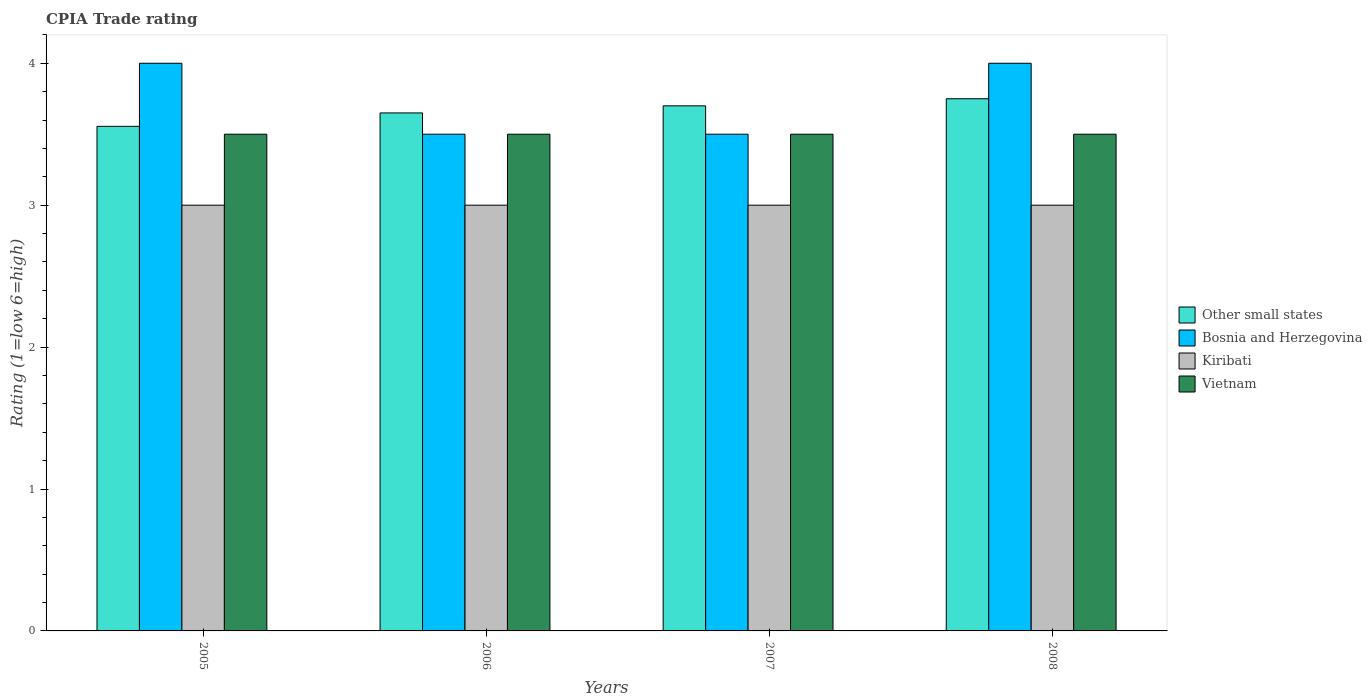Are the number of bars on each tick of the X-axis equal?
Keep it short and to the point. Yes. What is the label of the 4th group of bars from the left?
Your answer should be very brief. 2008. Across all years, what is the maximum CPIA rating in Bosnia and Herzegovina?
Your answer should be very brief. 4. Across all years, what is the minimum CPIA rating in Vietnam?
Provide a short and direct response. 3.5. In which year was the CPIA rating in Kiribati maximum?
Ensure brevity in your answer.  2005. In which year was the CPIA rating in Bosnia and Herzegovina minimum?
Offer a terse response. 2006. What is the total CPIA rating in Kiribati in the graph?
Make the answer very short. 12. What is the difference between the CPIA rating in Bosnia and Herzegovina in 2006 and that in 2008?
Make the answer very short. -0.5. What is the difference between the CPIA rating in Bosnia and Herzegovina in 2007 and the CPIA rating in Vietnam in 2008?
Keep it short and to the point. 0. What is the average CPIA rating in Other small states per year?
Your response must be concise. 3.66. What is the ratio of the CPIA rating in Kiribati in 2006 to that in 2008?
Offer a terse response. 1. Is the CPIA rating in Other small states in 2005 less than that in 2007?
Provide a short and direct response. Yes. What is the difference between the highest and the second highest CPIA rating in Vietnam?
Provide a short and direct response. 0. Is the sum of the CPIA rating in Other small states in 2005 and 2007 greater than the maximum CPIA rating in Bosnia and Herzegovina across all years?
Offer a very short reply. Yes. What does the 1st bar from the left in 2005 represents?
Keep it short and to the point. Other small states. What does the 1st bar from the right in 2006 represents?
Ensure brevity in your answer.  Vietnam. Are all the bars in the graph horizontal?
Your response must be concise. No. How many years are there in the graph?
Offer a terse response. 4. Are the values on the major ticks of Y-axis written in scientific E-notation?
Ensure brevity in your answer.  No. How are the legend labels stacked?
Ensure brevity in your answer.  Vertical. What is the title of the graph?
Offer a very short reply. CPIA Trade rating. What is the Rating (1=low 6=high) in Other small states in 2005?
Your answer should be very brief. 3.56. What is the Rating (1=low 6=high) in Bosnia and Herzegovina in 2005?
Offer a very short reply. 4. What is the Rating (1=low 6=high) in Other small states in 2006?
Ensure brevity in your answer.  3.65. What is the Rating (1=low 6=high) in Bosnia and Herzegovina in 2006?
Your response must be concise. 3.5. What is the Rating (1=low 6=high) of Kiribati in 2006?
Provide a short and direct response. 3. What is the Rating (1=low 6=high) of Kiribati in 2007?
Ensure brevity in your answer.  3. What is the Rating (1=low 6=high) in Other small states in 2008?
Your answer should be compact. 3.75. What is the Rating (1=low 6=high) in Bosnia and Herzegovina in 2008?
Offer a terse response. 4. What is the Rating (1=low 6=high) in Vietnam in 2008?
Offer a terse response. 3.5. Across all years, what is the maximum Rating (1=low 6=high) of Other small states?
Make the answer very short. 3.75. Across all years, what is the maximum Rating (1=low 6=high) in Bosnia and Herzegovina?
Offer a very short reply. 4. Across all years, what is the maximum Rating (1=low 6=high) in Kiribati?
Make the answer very short. 3. Across all years, what is the maximum Rating (1=low 6=high) in Vietnam?
Offer a terse response. 3.5. Across all years, what is the minimum Rating (1=low 6=high) in Other small states?
Your answer should be very brief. 3.56. Across all years, what is the minimum Rating (1=low 6=high) in Bosnia and Herzegovina?
Your answer should be compact. 3.5. Across all years, what is the minimum Rating (1=low 6=high) in Vietnam?
Make the answer very short. 3.5. What is the total Rating (1=low 6=high) of Other small states in the graph?
Offer a terse response. 14.66. What is the total Rating (1=low 6=high) of Bosnia and Herzegovina in the graph?
Provide a succinct answer. 15. What is the difference between the Rating (1=low 6=high) in Other small states in 2005 and that in 2006?
Offer a very short reply. -0.09. What is the difference between the Rating (1=low 6=high) of Other small states in 2005 and that in 2007?
Ensure brevity in your answer.  -0.14. What is the difference between the Rating (1=low 6=high) of Bosnia and Herzegovina in 2005 and that in 2007?
Make the answer very short. 0.5. What is the difference between the Rating (1=low 6=high) of Kiribati in 2005 and that in 2007?
Give a very brief answer. 0. What is the difference between the Rating (1=low 6=high) of Other small states in 2005 and that in 2008?
Offer a terse response. -0.19. What is the difference between the Rating (1=low 6=high) in Bosnia and Herzegovina in 2005 and that in 2008?
Ensure brevity in your answer.  0. What is the difference between the Rating (1=low 6=high) of Kiribati in 2005 and that in 2008?
Your answer should be very brief. 0. What is the difference between the Rating (1=low 6=high) in Kiribati in 2006 and that in 2007?
Ensure brevity in your answer.  0. What is the difference between the Rating (1=low 6=high) of Bosnia and Herzegovina in 2006 and that in 2008?
Provide a succinct answer. -0.5. What is the difference between the Rating (1=low 6=high) of Kiribati in 2007 and that in 2008?
Your answer should be very brief. 0. What is the difference between the Rating (1=low 6=high) in Other small states in 2005 and the Rating (1=low 6=high) in Bosnia and Herzegovina in 2006?
Your answer should be very brief. 0.06. What is the difference between the Rating (1=low 6=high) of Other small states in 2005 and the Rating (1=low 6=high) of Kiribati in 2006?
Make the answer very short. 0.56. What is the difference between the Rating (1=low 6=high) of Other small states in 2005 and the Rating (1=low 6=high) of Vietnam in 2006?
Your answer should be compact. 0.06. What is the difference between the Rating (1=low 6=high) in Bosnia and Herzegovina in 2005 and the Rating (1=low 6=high) in Kiribati in 2006?
Your response must be concise. 1. What is the difference between the Rating (1=low 6=high) of Other small states in 2005 and the Rating (1=low 6=high) of Bosnia and Herzegovina in 2007?
Offer a very short reply. 0.06. What is the difference between the Rating (1=low 6=high) in Other small states in 2005 and the Rating (1=low 6=high) in Kiribati in 2007?
Your answer should be compact. 0.56. What is the difference between the Rating (1=low 6=high) of Other small states in 2005 and the Rating (1=low 6=high) of Vietnam in 2007?
Offer a very short reply. 0.06. What is the difference between the Rating (1=low 6=high) of Bosnia and Herzegovina in 2005 and the Rating (1=low 6=high) of Kiribati in 2007?
Offer a terse response. 1. What is the difference between the Rating (1=low 6=high) of Other small states in 2005 and the Rating (1=low 6=high) of Bosnia and Herzegovina in 2008?
Provide a succinct answer. -0.44. What is the difference between the Rating (1=low 6=high) of Other small states in 2005 and the Rating (1=low 6=high) of Kiribati in 2008?
Make the answer very short. 0.56. What is the difference between the Rating (1=low 6=high) in Other small states in 2005 and the Rating (1=low 6=high) in Vietnam in 2008?
Make the answer very short. 0.06. What is the difference between the Rating (1=low 6=high) in Other small states in 2006 and the Rating (1=low 6=high) in Bosnia and Herzegovina in 2007?
Your response must be concise. 0.15. What is the difference between the Rating (1=low 6=high) of Other small states in 2006 and the Rating (1=low 6=high) of Kiribati in 2007?
Offer a terse response. 0.65. What is the difference between the Rating (1=low 6=high) of Bosnia and Herzegovina in 2006 and the Rating (1=low 6=high) of Kiribati in 2007?
Offer a terse response. 0.5. What is the difference between the Rating (1=low 6=high) in Other small states in 2006 and the Rating (1=low 6=high) in Bosnia and Herzegovina in 2008?
Your answer should be very brief. -0.35. What is the difference between the Rating (1=low 6=high) in Other small states in 2006 and the Rating (1=low 6=high) in Kiribati in 2008?
Offer a terse response. 0.65. What is the difference between the Rating (1=low 6=high) of Kiribati in 2006 and the Rating (1=low 6=high) of Vietnam in 2008?
Your response must be concise. -0.5. What is the difference between the Rating (1=low 6=high) of Other small states in 2007 and the Rating (1=low 6=high) of Kiribati in 2008?
Give a very brief answer. 0.7. What is the difference between the Rating (1=low 6=high) of Other small states in 2007 and the Rating (1=low 6=high) of Vietnam in 2008?
Your answer should be very brief. 0.2. What is the difference between the Rating (1=low 6=high) of Bosnia and Herzegovina in 2007 and the Rating (1=low 6=high) of Kiribati in 2008?
Ensure brevity in your answer.  0.5. What is the average Rating (1=low 6=high) in Other small states per year?
Give a very brief answer. 3.66. What is the average Rating (1=low 6=high) of Bosnia and Herzegovina per year?
Make the answer very short. 3.75. What is the average Rating (1=low 6=high) in Kiribati per year?
Make the answer very short. 3. What is the average Rating (1=low 6=high) of Vietnam per year?
Provide a short and direct response. 3.5. In the year 2005, what is the difference between the Rating (1=low 6=high) of Other small states and Rating (1=low 6=high) of Bosnia and Herzegovina?
Provide a short and direct response. -0.44. In the year 2005, what is the difference between the Rating (1=low 6=high) in Other small states and Rating (1=low 6=high) in Kiribati?
Offer a terse response. 0.56. In the year 2005, what is the difference between the Rating (1=low 6=high) in Other small states and Rating (1=low 6=high) in Vietnam?
Your answer should be compact. 0.06. In the year 2005, what is the difference between the Rating (1=low 6=high) of Bosnia and Herzegovina and Rating (1=low 6=high) of Kiribati?
Provide a short and direct response. 1. In the year 2005, what is the difference between the Rating (1=low 6=high) of Kiribati and Rating (1=low 6=high) of Vietnam?
Keep it short and to the point. -0.5. In the year 2006, what is the difference between the Rating (1=low 6=high) in Other small states and Rating (1=low 6=high) in Bosnia and Herzegovina?
Ensure brevity in your answer.  0.15. In the year 2006, what is the difference between the Rating (1=low 6=high) of Other small states and Rating (1=low 6=high) of Kiribati?
Keep it short and to the point. 0.65. In the year 2006, what is the difference between the Rating (1=low 6=high) of Other small states and Rating (1=low 6=high) of Vietnam?
Your response must be concise. 0.15. In the year 2006, what is the difference between the Rating (1=low 6=high) of Bosnia and Herzegovina and Rating (1=low 6=high) of Kiribati?
Give a very brief answer. 0.5. In the year 2006, what is the difference between the Rating (1=low 6=high) of Bosnia and Herzegovina and Rating (1=low 6=high) of Vietnam?
Your answer should be compact. 0. In the year 2006, what is the difference between the Rating (1=low 6=high) of Kiribati and Rating (1=low 6=high) of Vietnam?
Offer a very short reply. -0.5. In the year 2007, what is the difference between the Rating (1=low 6=high) in Other small states and Rating (1=low 6=high) in Bosnia and Herzegovina?
Keep it short and to the point. 0.2. In the year 2007, what is the difference between the Rating (1=low 6=high) of Kiribati and Rating (1=low 6=high) of Vietnam?
Provide a succinct answer. -0.5. In the year 2008, what is the difference between the Rating (1=low 6=high) in Other small states and Rating (1=low 6=high) in Bosnia and Herzegovina?
Your response must be concise. -0.25. In the year 2008, what is the difference between the Rating (1=low 6=high) of Bosnia and Herzegovina and Rating (1=low 6=high) of Vietnam?
Make the answer very short. 0.5. In the year 2008, what is the difference between the Rating (1=low 6=high) of Kiribati and Rating (1=low 6=high) of Vietnam?
Give a very brief answer. -0.5. What is the ratio of the Rating (1=low 6=high) in Other small states in 2005 to that in 2006?
Your response must be concise. 0.97. What is the ratio of the Rating (1=low 6=high) of Bosnia and Herzegovina in 2005 to that in 2006?
Provide a succinct answer. 1.14. What is the ratio of the Rating (1=low 6=high) of Other small states in 2005 to that in 2007?
Offer a terse response. 0.96. What is the ratio of the Rating (1=low 6=high) of Bosnia and Herzegovina in 2005 to that in 2007?
Your answer should be very brief. 1.14. What is the ratio of the Rating (1=low 6=high) of Vietnam in 2005 to that in 2007?
Ensure brevity in your answer.  1. What is the ratio of the Rating (1=low 6=high) of Other small states in 2005 to that in 2008?
Your response must be concise. 0.95. What is the ratio of the Rating (1=low 6=high) of Other small states in 2006 to that in 2007?
Your answer should be compact. 0.99. What is the ratio of the Rating (1=low 6=high) of Other small states in 2006 to that in 2008?
Keep it short and to the point. 0.97. What is the ratio of the Rating (1=low 6=high) in Kiribati in 2006 to that in 2008?
Make the answer very short. 1. What is the ratio of the Rating (1=low 6=high) of Vietnam in 2006 to that in 2008?
Provide a succinct answer. 1. What is the ratio of the Rating (1=low 6=high) in Other small states in 2007 to that in 2008?
Offer a terse response. 0.99. What is the ratio of the Rating (1=low 6=high) in Bosnia and Herzegovina in 2007 to that in 2008?
Make the answer very short. 0.88. What is the difference between the highest and the second highest Rating (1=low 6=high) in Other small states?
Provide a succinct answer. 0.05. What is the difference between the highest and the second highest Rating (1=low 6=high) of Bosnia and Herzegovina?
Keep it short and to the point. 0. What is the difference between the highest and the second highest Rating (1=low 6=high) in Vietnam?
Your answer should be very brief. 0. What is the difference between the highest and the lowest Rating (1=low 6=high) of Other small states?
Your answer should be compact. 0.19. What is the difference between the highest and the lowest Rating (1=low 6=high) in Bosnia and Herzegovina?
Offer a terse response. 0.5. What is the difference between the highest and the lowest Rating (1=low 6=high) of Kiribati?
Your answer should be compact. 0. 